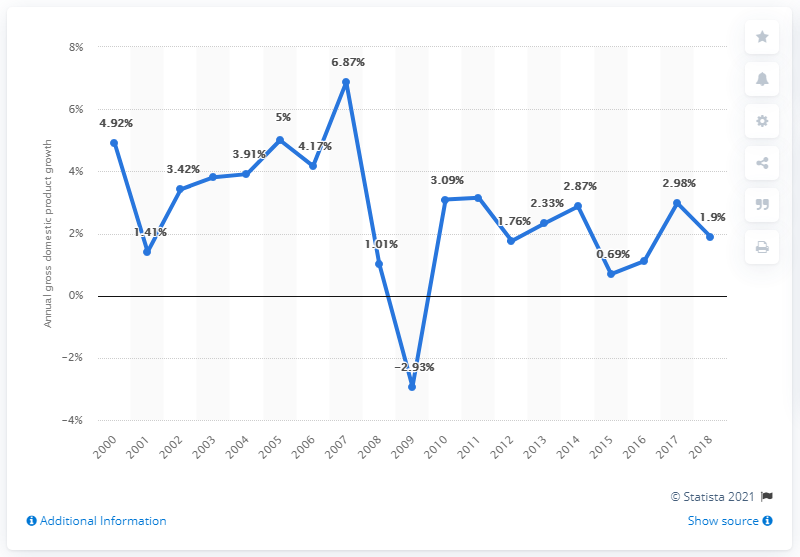Point out several critical features in this image. According to the data, Canada's Gross Domestic Product (GDP) increased by 1.9% in 2018. The average between 2017 and 2018 of GDP is 2.44. In 2009, the Gross Domestic Product (GDP) of Canada was negative, indicating a period of economic downturn and contraction. 